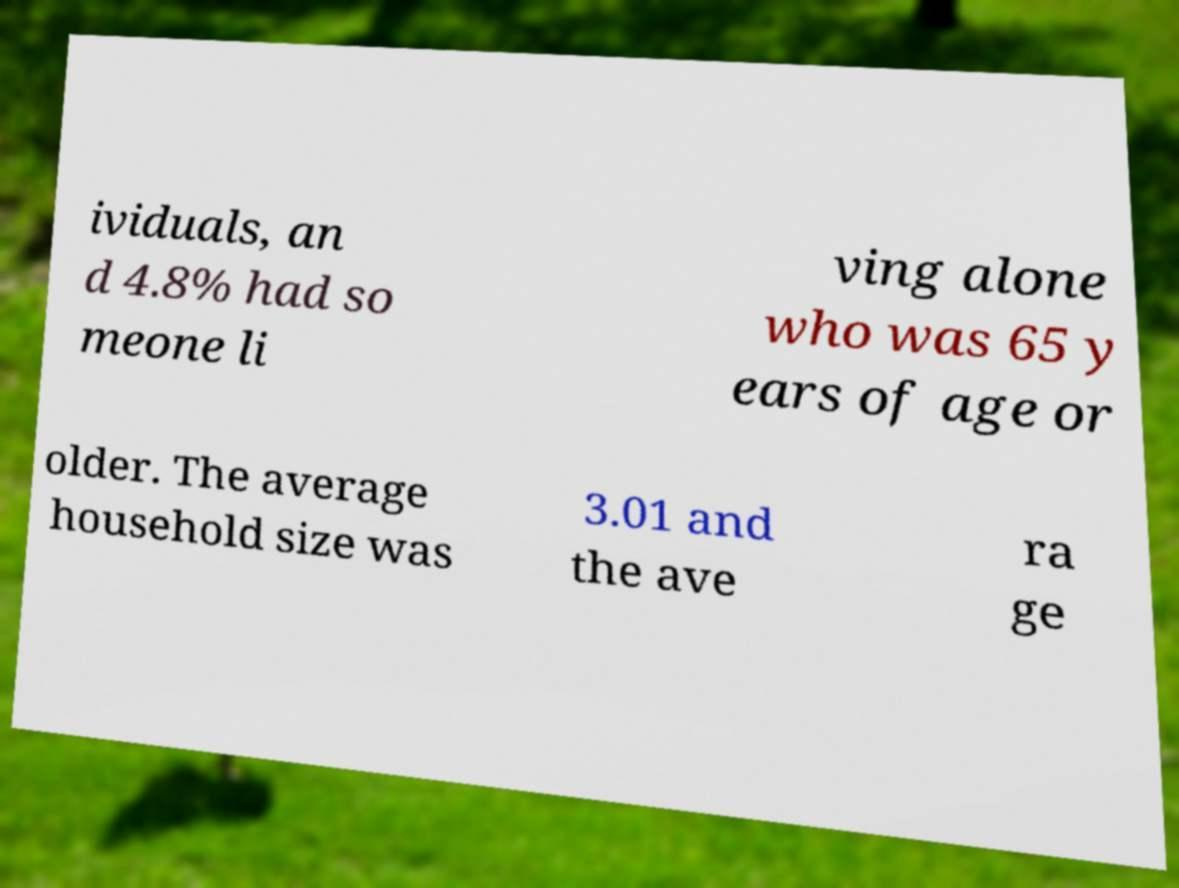Could you assist in decoding the text presented in this image and type it out clearly? ividuals, an d 4.8% had so meone li ving alone who was 65 y ears of age or older. The average household size was 3.01 and the ave ra ge 